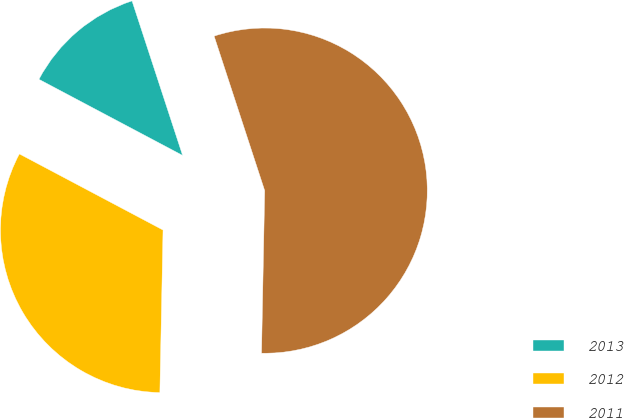Convert chart. <chart><loc_0><loc_0><loc_500><loc_500><pie_chart><fcel>2013<fcel>2012<fcel>2011<nl><fcel>12.21%<fcel>32.44%<fcel>55.34%<nl></chart> 